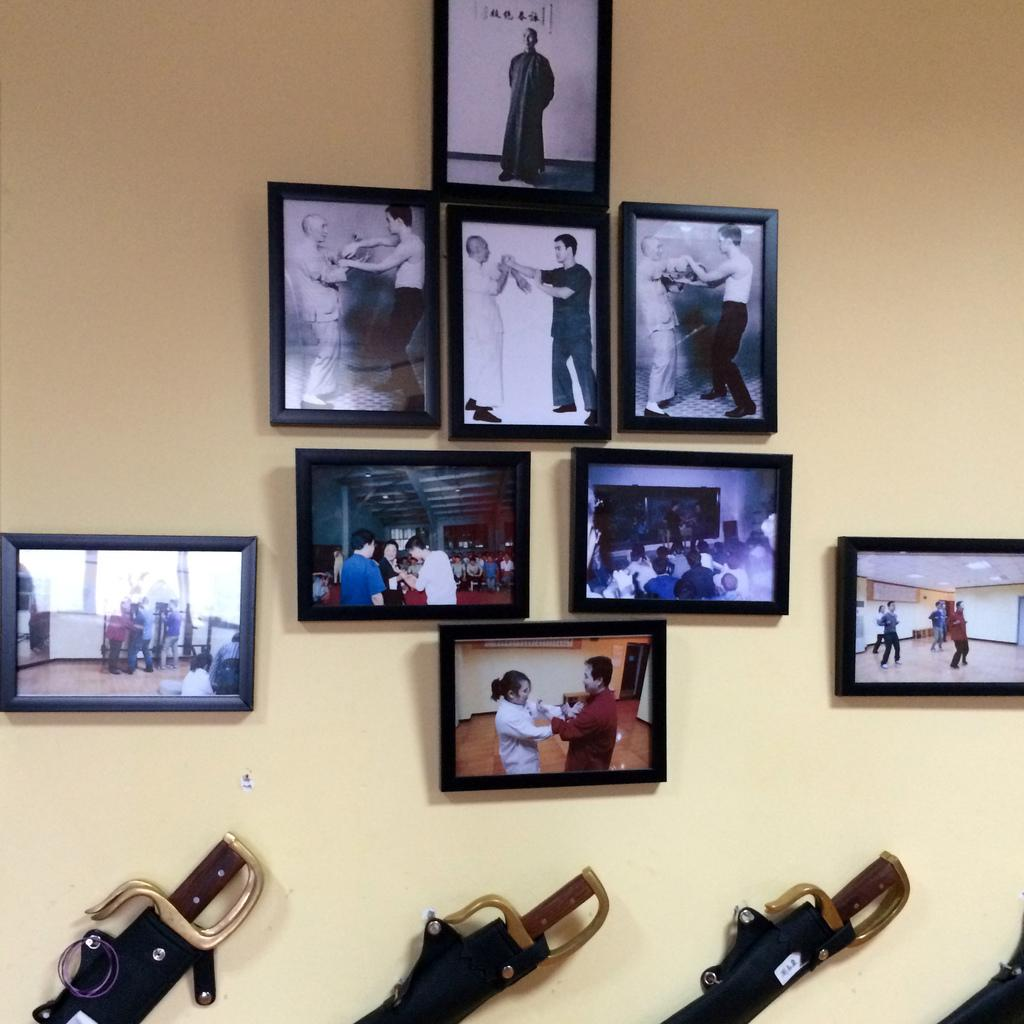What is hanging on the wall in the image? There are frames and swords on the wall. Can you describe the frames on the wall? Unfortunately, the details of the frames cannot be determined from the provided facts. How many swords are on the wall? The number of swords on the wall cannot be determined from the provided facts. What type of scent can be detected from the ducks in the image? There are no ducks present in the image, so it is not possible to determine any scent associated with them. 